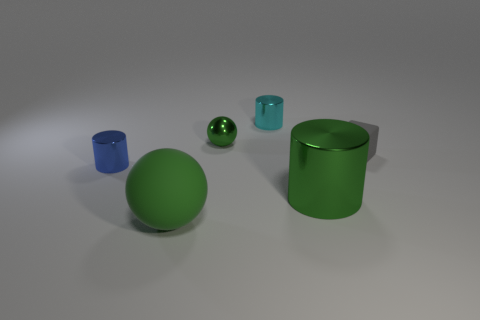The rubber object that is behind the tiny cylinder that is to the left of the cyan metallic cylinder is what shape?
Your answer should be very brief. Cube. Is there anything else that has the same color as the large matte ball?
Your answer should be compact. Yes. Is there a large ball in front of the green thing that is behind the small gray object that is in front of the small green shiny thing?
Offer a very short reply. Yes. There is a shiny cylinder to the right of the cyan thing; is it the same color as the thing on the right side of the big green metallic object?
Provide a succinct answer. No. What material is the cyan thing that is the same size as the gray matte cube?
Provide a succinct answer. Metal. There is a shiny cylinder that is to the left of the green ball behind the tiny object that is to the left of the small green shiny thing; what is its size?
Keep it short and to the point. Small. What number of other things are there of the same material as the large ball
Offer a terse response. 1. What size is the metal cylinder that is to the left of the green matte thing?
Keep it short and to the point. Small. How many things are to the left of the cube and right of the small cyan cylinder?
Offer a very short reply. 1. There is a large object that is on the right side of the green shiny object behind the small gray matte block; what is its material?
Offer a terse response. Metal. 